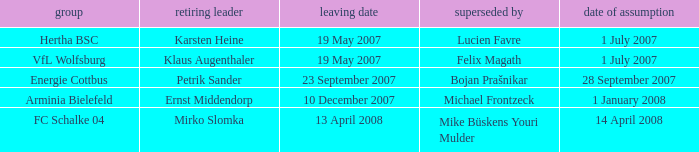When was the appointment date for VFL Wolfsburg? 1 July 2007. 